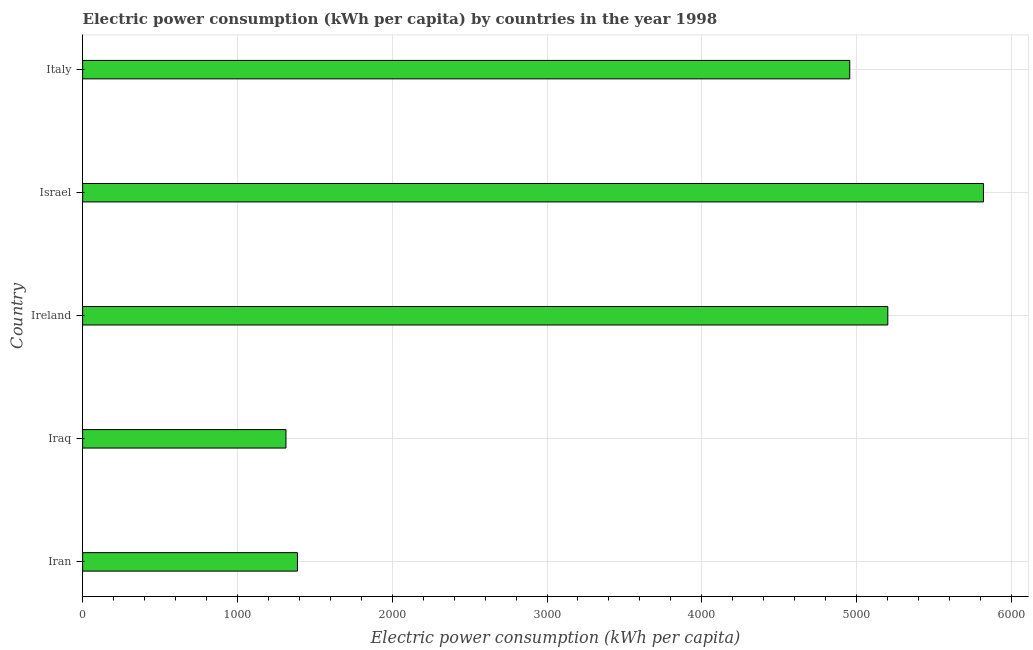Does the graph contain any zero values?
Your answer should be compact. No. Does the graph contain grids?
Offer a very short reply. Yes. What is the title of the graph?
Provide a succinct answer. Electric power consumption (kWh per capita) by countries in the year 1998. What is the label or title of the X-axis?
Offer a very short reply. Electric power consumption (kWh per capita). What is the electric power consumption in Ireland?
Your answer should be compact. 5201.61. Across all countries, what is the maximum electric power consumption?
Offer a very short reply. 5819.46. Across all countries, what is the minimum electric power consumption?
Make the answer very short. 1313.46. In which country was the electric power consumption minimum?
Your answer should be very brief. Iraq. What is the sum of the electric power consumption?
Keep it short and to the point. 1.87e+04. What is the difference between the electric power consumption in Israel and Italy?
Give a very brief answer. 863.74. What is the average electric power consumption per country?
Offer a terse response. 3735.64. What is the median electric power consumption?
Your answer should be very brief. 4955.72. In how many countries, is the electric power consumption greater than 5400 kWh per capita?
Keep it short and to the point. 1. What is the ratio of the electric power consumption in Ireland to that in Israel?
Offer a very short reply. 0.89. What is the difference between the highest and the second highest electric power consumption?
Give a very brief answer. 617.85. What is the difference between the highest and the lowest electric power consumption?
Provide a short and direct response. 4506. In how many countries, is the electric power consumption greater than the average electric power consumption taken over all countries?
Give a very brief answer. 3. How many bars are there?
Keep it short and to the point. 5. What is the difference between two consecutive major ticks on the X-axis?
Give a very brief answer. 1000. What is the Electric power consumption (kWh per capita) in Iran?
Keep it short and to the point. 1387.94. What is the Electric power consumption (kWh per capita) of Iraq?
Give a very brief answer. 1313.46. What is the Electric power consumption (kWh per capita) in Ireland?
Give a very brief answer. 5201.61. What is the Electric power consumption (kWh per capita) of Israel?
Your answer should be very brief. 5819.46. What is the Electric power consumption (kWh per capita) in Italy?
Ensure brevity in your answer.  4955.72. What is the difference between the Electric power consumption (kWh per capita) in Iran and Iraq?
Ensure brevity in your answer.  74.47. What is the difference between the Electric power consumption (kWh per capita) in Iran and Ireland?
Your answer should be very brief. -3813.68. What is the difference between the Electric power consumption (kWh per capita) in Iran and Israel?
Provide a short and direct response. -4431.53. What is the difference between the Electric power consumption (kWh per capita) in Iran and Italy?
Provide a short and direct response. -3567.79. What is the difference between the Electric power consumption (kWh per capita) in Iraq and Ireland?
Give a very brief answer. -3888.15. What is the difference between the Electric power consumption (kWh per capita) in Iraq and Israel?
Ensure brevity in your answer.  -4506. What is the difference between the Electric power consumption (kWh per capita) in Iraq and Italy?
Provide a short and direct response. -3642.26. What is the difference between the Electric power consumption (kWh per capita) in Ireland and Israel?
Make the answer very short. -617.85. What is the difference between the Electric power consumption (kWh per capita) in Ireland and Italy?
Provide a succinct answer. 245.89. What is the difference between the Electric power consumption (kWh per capita) in Israel and Italy?
Provide a short and direct response. 863.74. What is the ratio of the Electric power consumption (kWh per capita) in Iran to that in Iraq?
Your answer should be very brief. 1.06. What is the ratio of the Electric power consumption (kWh per capita) in Iran to that in Ireland?
Offer a terse response. 0.27. What is the ratio of the Electric power consumption (kWh per capita) in Iran to that in Israel?
Your answer should be compact. 0.24. What is the ratio of the Electric power consumption (kWh per capita) in Iran to that in Italy?
Ensure brevity in your answer.  0.28. What is the ratio of the Electric power consumption (kWh per capita) in Iraq to that in Ireland?
Your answer should be very brief. 0.25. What is the ratio of the Electric power consumption (kWh per capita) in Iraq to that in Israel?
Keep it short and to the point. 0.23. What is the ratio of the Electric power consumption (kWh per capita) in Iraq to that in Italy?
Ensure brevity in your answer.  0.27. What is the ratio of the Electric power consumption (kWh per capita) in Ireland to that in Israel?
Provide a short and direct response. 0.89. What is the ratio of the Electric power consumption (kWh per capita) in Ireland to that in Italy?
Offer a terse response. 1.05. What is the ratio of the Electric power consumption (kWh per capita) in Israel to that in Italy?
Offer a very short reply. 1.17. 